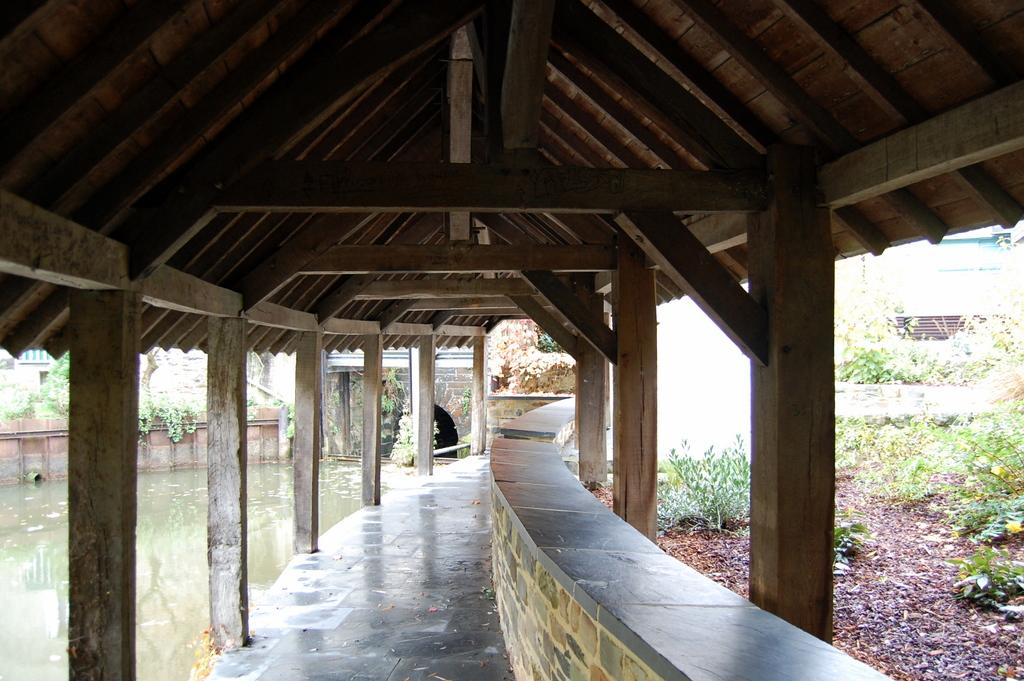What is visible in the image? Water, a wall, plants, wooden pillars, and a roof are visible in the image. Can you describe the structure in the image? The structure in the image has a wall, wooden pillars, and a roof. What type of vegetation is present in the image? Plants are present in the image. How much profit did the crook make from the fowl in the image? There is no crook, profit, or fowl present in the image. 